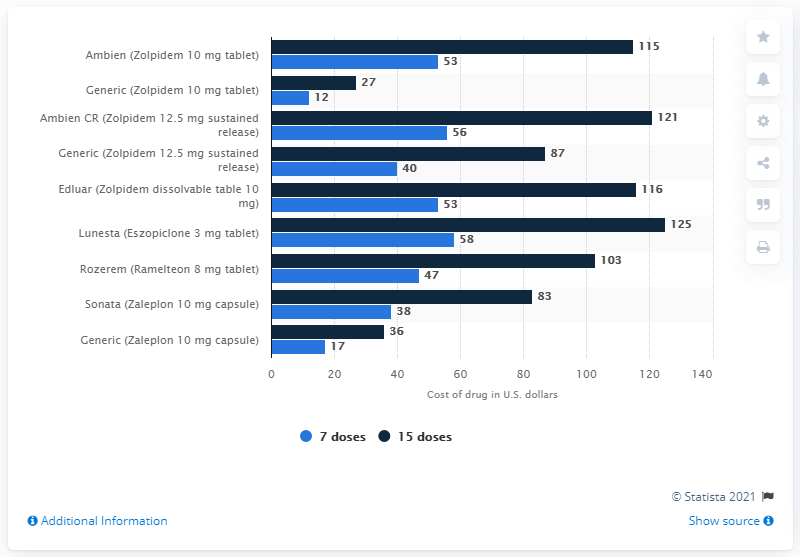Give some essential details in this illustration. The cost of a 10 mg tablet of Ambien for seven doses was approximately $53. 